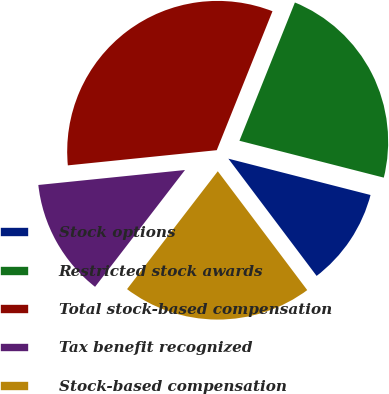<chart> <loc_0><loc_0><loc_500><loc_500><pie_chart><fcel>Stock options<fcel>Restricted stock awards<fcel>Total stock-based compensation<fcel>Tax benefit recognized<fcel>Stock-based compensation<nl><fcel>10.75%<fcel>22.91%<fcel>32.69%<fcel>12.94%<fcel>20.71%<nl></chart> 